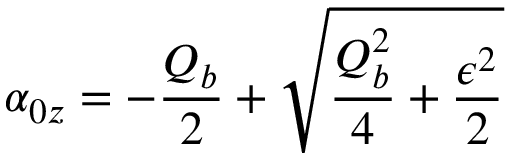Convert formula to latex. <formula><loc_0><loc_0><loc_500><loc_500>\alpha _ { 0 z } = - \frac { Q _ { b } } { 2 } + \sqrt { \frac { Q _ { b } ^ { 2 } } { 4 } + \frac { \epsilon ^ { 2 } } { 2 } }</formula> 